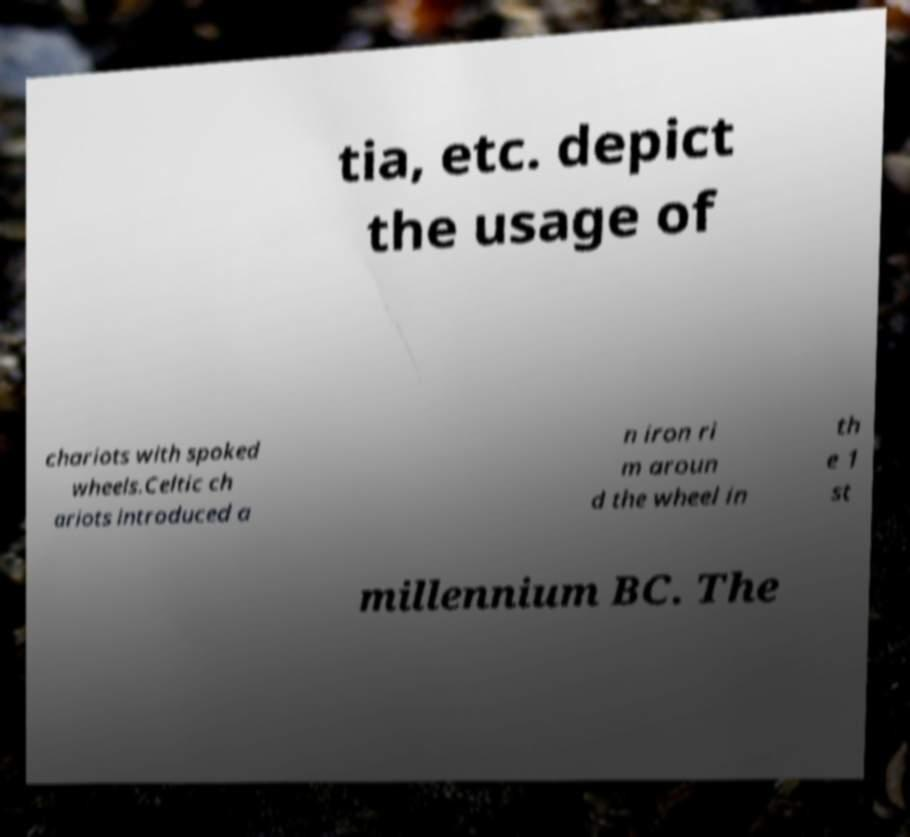Could you assist in decoding the text presented in this image and type it out clearly? tia, etc. depict the usage of chariots with spoked wheels.Celtic ch ariots introduced a n iron ri m aroun d the wheel in th e 1 st millennium BC. The 